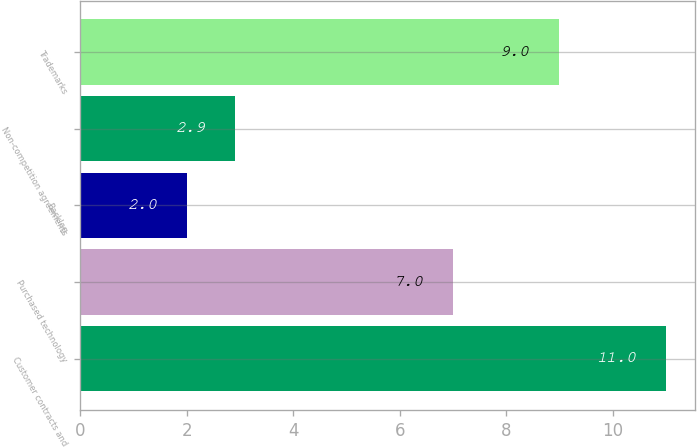Convert chart. <chart><loc_0><loc_0><loc_500><loc_500><bar_chart><fcel>Customer contracts and<fcel>Purchased technology<fcel>Backlog<fcel>Non-competition agreements<fcel>Trademarks<nl><fcel>11<fcel>7<fcel>2<fcel>2.9<fcel>9<nl></chart> 